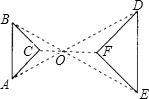What can we infer about the line segments connecting the vertices of the two triangles? The line segments connecting the vertices of the two triangles imply that these points are related by a scale transformation centered at point 'O'. This setup often indicates a radial symmetry, suggesting that each vertex of the smaller triangle, ABC, is projected outwards to its corresponding vertex of the larger triangle, DEF, through 'O'. The exact scale factor could be determined if the lengths of corresponding sides were known. This concept is central to many geometrical constructions and proofs, illustrating how triangles can be expanded or reduced while retaining their shape. 